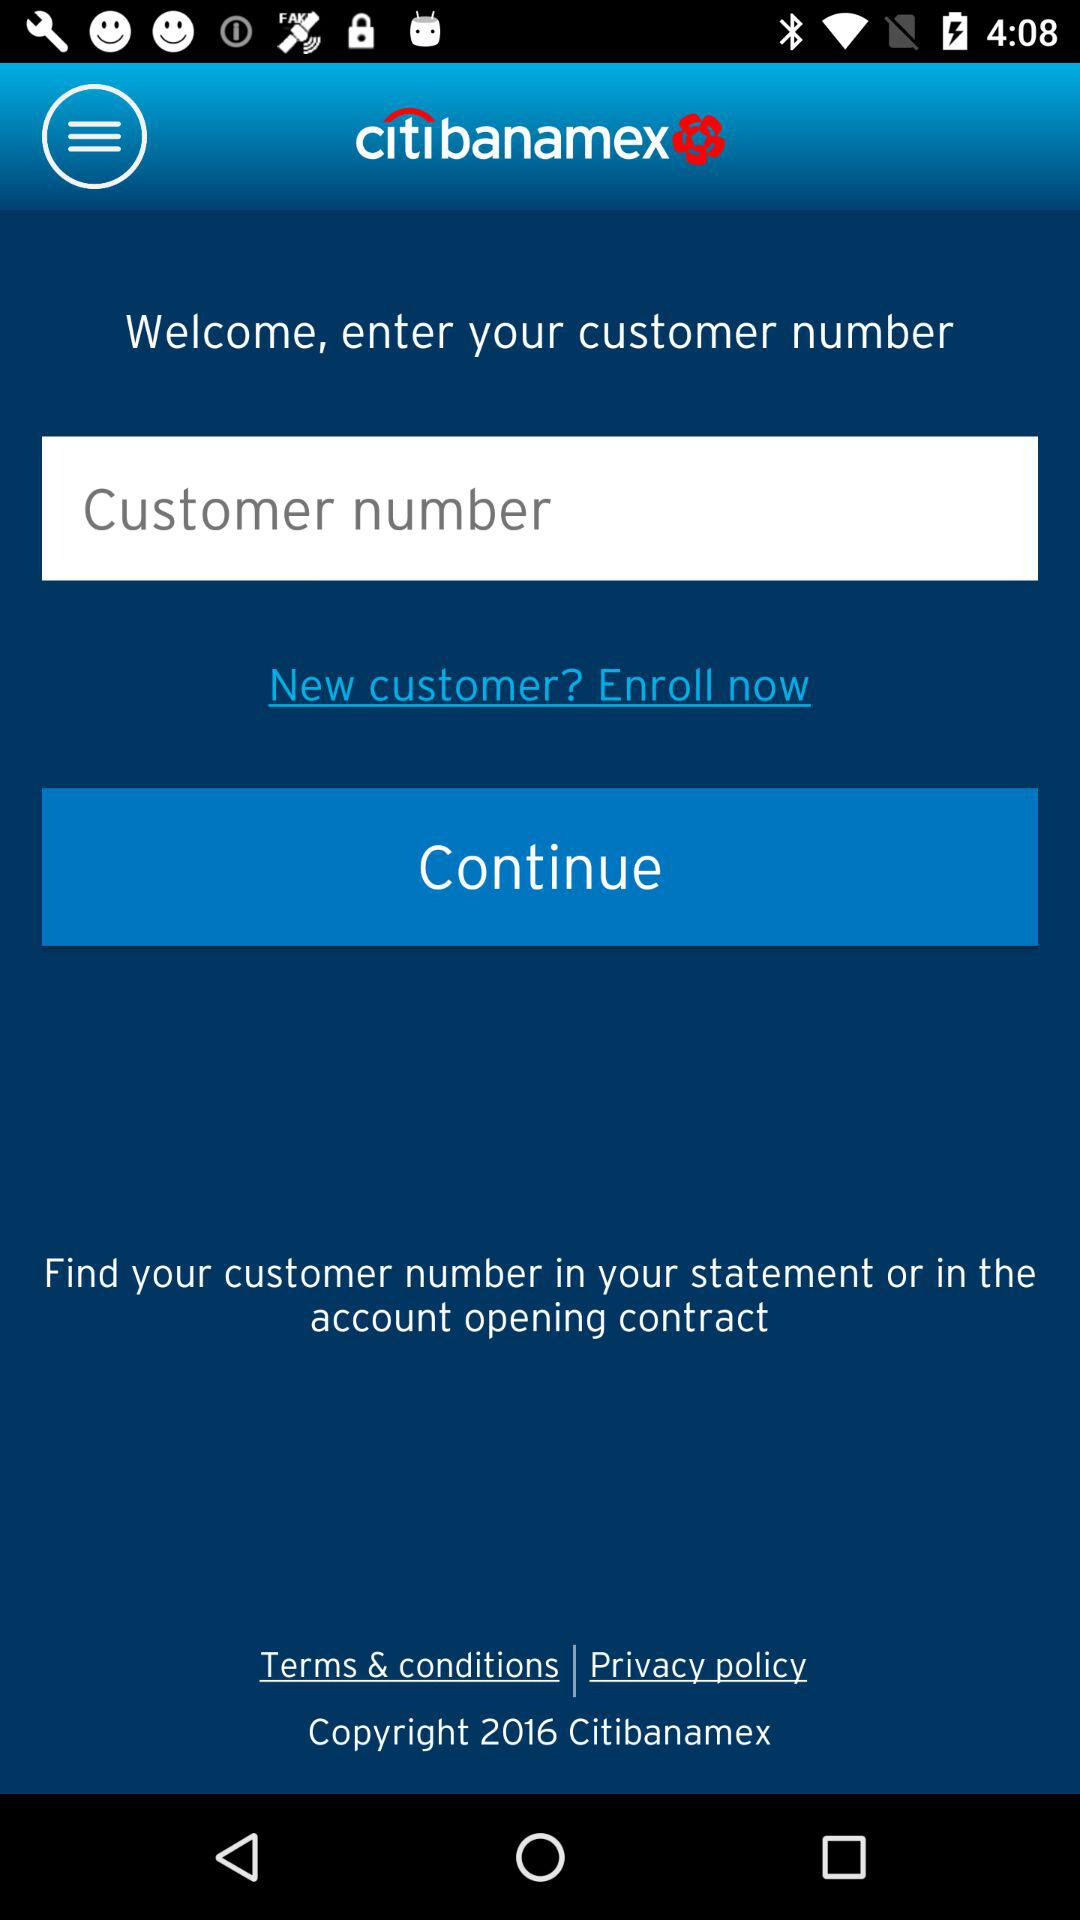What is the name of the application? The name of the application is "citi banamex". 